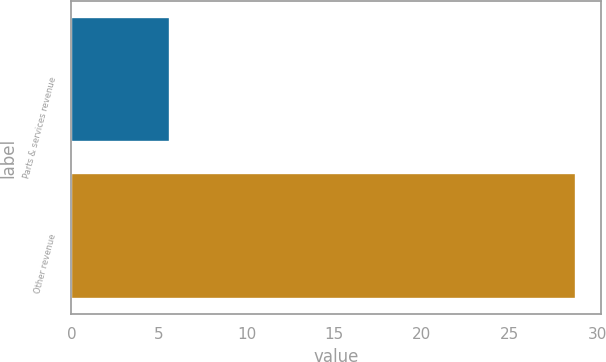<chart> <loc_0><loc_0><loc_500><loc_500><bar_chart><fcel>Parts & services revenue<fcel>Other revenue<nl><fcel>5.6<fcel>28.8<nl></chart> 